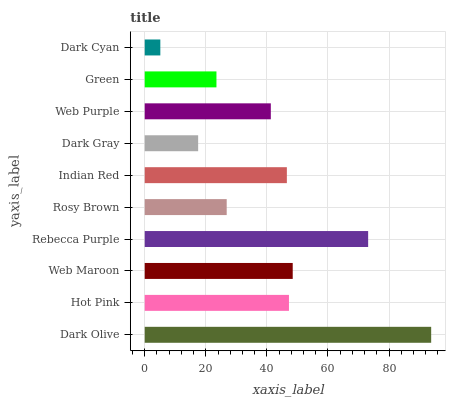Is Dark Cyan the minimum?
Answer yes or no. Yes. Is Dark Olive the maximum?
Answer yes or no. Yes. Is Hot Pink the minimum?
Answer yes or no. No. Is Hot Pink the maximum?
Answer yes or no. No. Is Dark Olive greater than Hot Pink?
Answer yes or no. Yes. Is Hot Pink less than Dark Olive?
Answer yes or no. Yes. Is Hot Pink greater than Dark Olive?
Answer yes or no. No. Is Dark Olive less than Hot Pink?
Answer yes or no. No. Is Indian Red the high median?
Answer yes or no. Yes. Is Web Purple the low median?
Answer yes or no. Yes. Is Green the high median?
Answer yes or no. No. Is Rosy Brown the low median?
Answer yes or no. No. 